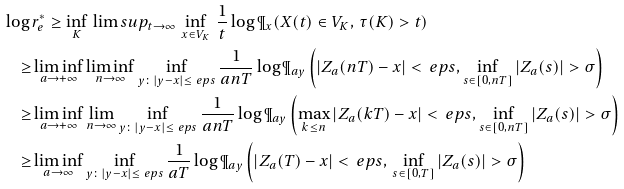<formula> <loc_0><loc_0><loc_500><loc_500>\log \, & r ^ { * } _ { e } \geq \inf _ { K } \, \lim s u p _ { t \to \infty } \, \inf _ { x \in V _ { K } } \, \frac { 1 } { t } \log \P _ { x } ( X ( t ) \in V _ { K } , \, \tau ( K ) > t ) \\ \geq & \liminf _ { a \to + \infty } \liminf _ { n \to \infty } \inf _ { y \colon | y - x | \leq \ e p s } \frac { 1 } { a n T } \log \P _ { a y } \left ( | Z _ { a } ( n T ) - x | < \ e p s , \inf _ { s \in [ 0 , n T ] } | Z _ { a } ( s ) | > \sigma \right ) \\ \geq & \liminf _ { a \to + \infty } \lim _ { n \to \infty } \inf _ { y \colon | y - x | \leq \ e p s } \frac { 1 } { a n T } \log \P _ { a y } \left ( \max _ { k \leq n } | Z _ { a } ( k T ) - x | < \ e p s , \inf _ { s \in [ 0 , n T ] } | Z _ { a } ( s ) | > \sigma \right ) \\ \geq & \liminf _ { a \to \infty } \inf _ { y \colon | y - x | \leq \ e p s } \frac { 1 } { a T } \log \P _ { a y } \left ( | Z _ { a } ( T ) - x | < \ e p s , \, \inf _ { s \in [ 0 , T ] } | Z _ { a } ( s ) | > \sigma \right )</formula> 